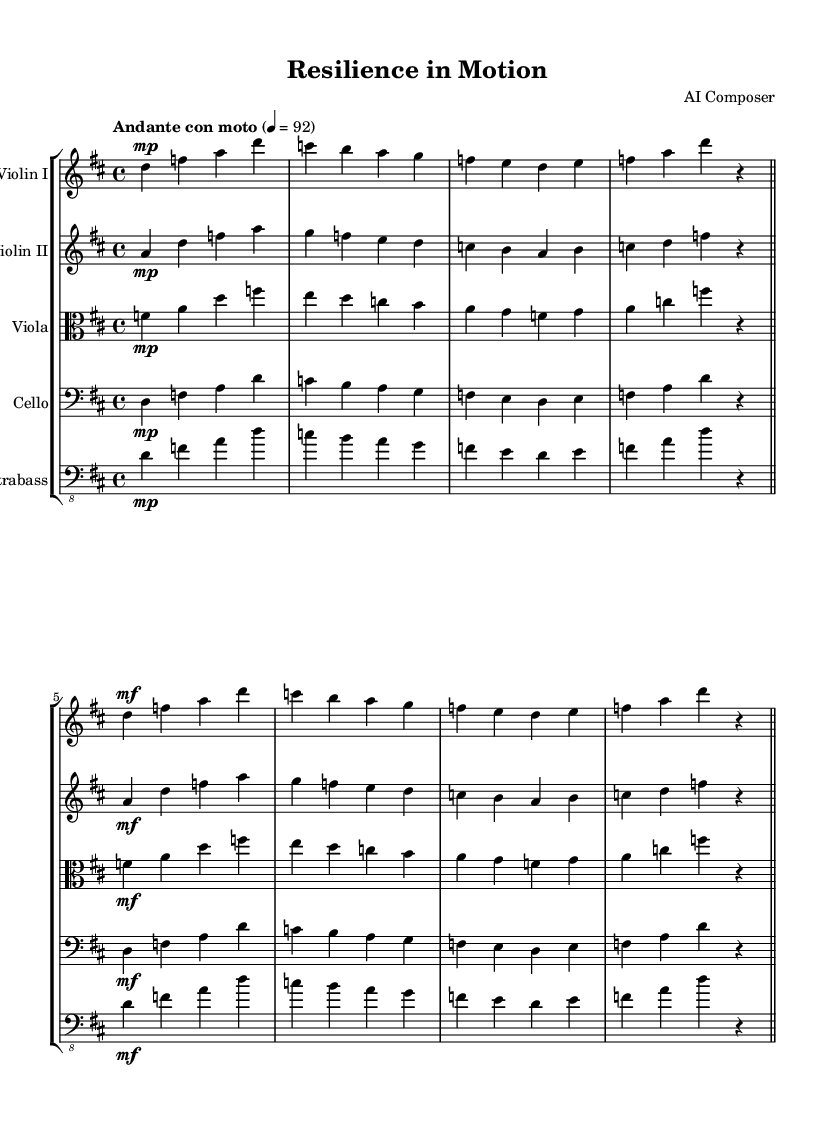what is the key signature of this music? The key signature is indicated by the number of sharps or flats present on the staff at the beginning of the piece. In this symphony, there is two sharps, which represents D major.
Answer: D major what is the time signature of this music? The time signature is found at the beginning of the piece, represented by the two numbers next to each other. In this case, the time signature is 4/4, indicating four beats in each measure.
Answer: 4/4 what is the tempo marking of this music? The tempo marking is indicated at the beginning of the piece, specifying how fast the music should be played. Here, it is "Andante con moto," which means moderately slow with some movement.
Answer: Andante con moto how many measures are in the first system? To find the number of measures in the first system, one needs to count the bar lines. In this instance, there are four measures in the first system.
Answer: four what is the dynamic marking for the first violin in the first system? The dynamic marking is indicated before the notes and shows how loudly or softly the section should be played. In the first system for the first violin, it starts with a "mp," indicating a moderately soft sound.
Answer: mp which instruments are included in this symphony? The instruments can be determined by looking at the staff headings that display each instrument’s name. In this symphony, the instruments are Violin I, Violin II, Viola, Cello, and Contrabass.
Answer: Violin I, Violin II, Viola, Cello, Contrabass 